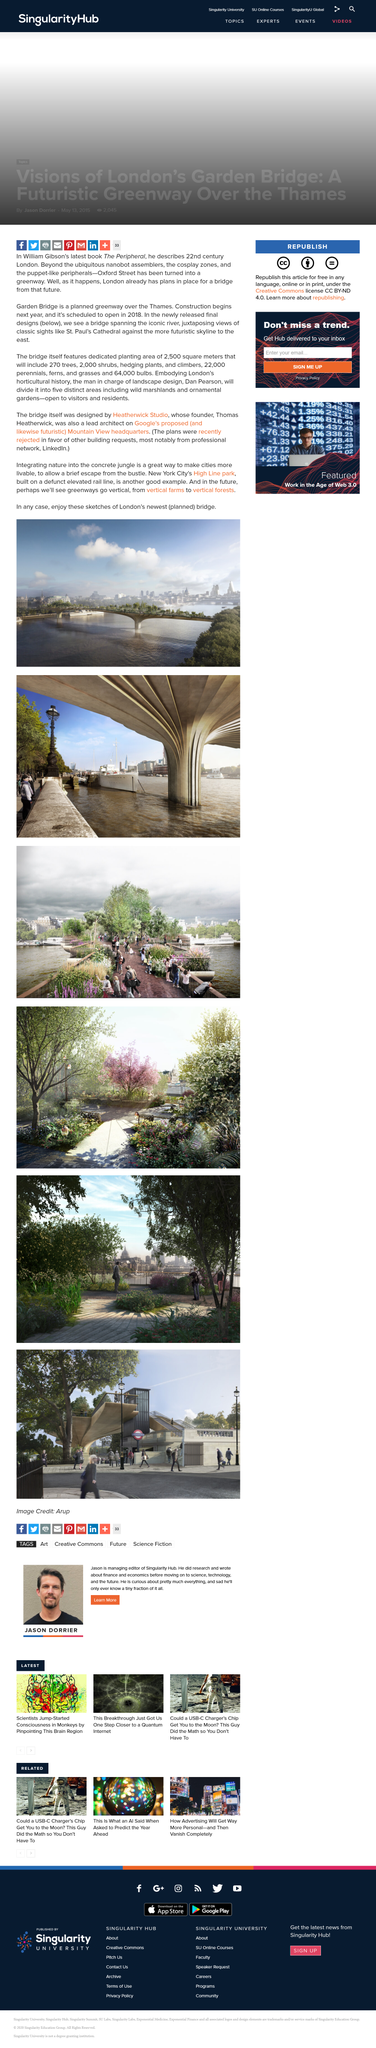Indicate a few pertinent items in this graphic. Two thousand shrubs will be located on the bridge. The High Line Park is located in New York City. Heatherwick Studio designed London's newest planned bridge. 